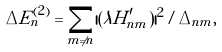<formula> <loc_0><loc_0><loc_500><loc_500>\Delta E _ { n } ^ { ( 2 ) } = \sum _ { m \neq n } | ( \lambda H _ { n m } ^ { \prime } ) | ^ { 2 } / \Delta _ { n m } ,</formula> 